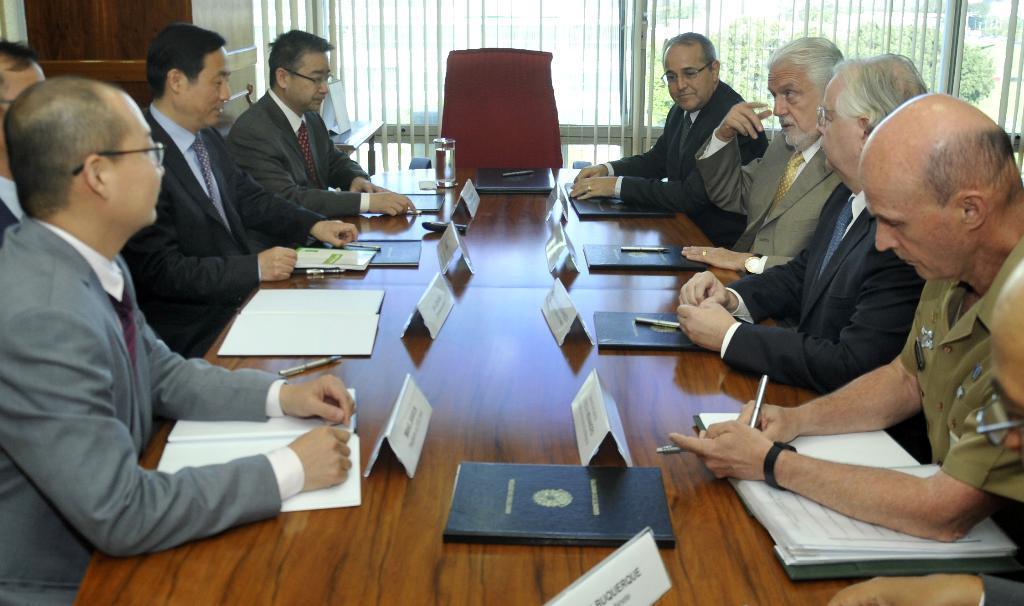How would you summarize this image in a sentence or two? In the middle of the image we can see a table, on the table there are some books, pens and glass. Surrounding the table few people are sitting and holding some pens. Behind them there is wall. Through the wall we can see some trees. 